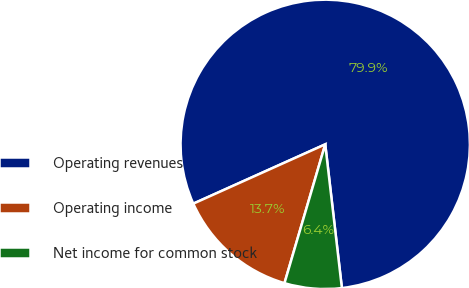<chart> <loc_0><loc_0><loc_500><loc_500><pie_chart><fcel>Operating revenues<fcel>Operating income<fcel>Net income for common stock<nl><fcel>79.88%<fcel>13.73%<fcel>6.38%<nl></chart> 